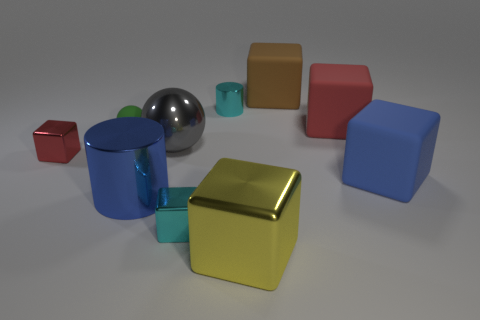Subtract all big red blocks. How many blocks are left? 5 Subtract all brown blocks. How many blocks are left? 5 Subtract all green blocks. Subtract all yellow balls. How many blocks are left? 6 Subtract all spheres. How many objects are left? 8 Add 4 big blocks. How many big blocks exist? 8 Subtract 0 brown spheres. How many objects are left? 10 Subtract all big blue rubber cylinders. Subtract all brown objects. How many objects are left? 9 Add 3 big gray things. How many big gray things are left? 4 